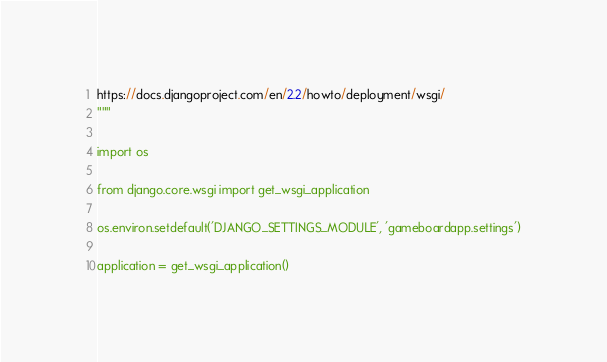Convert code to text. <code><loc_0><loc_0><loc_500><loc_500><_Python_>https://docs.djangoproject.com/en/2.2/howto/deployment/wsgi/
"""

import os

from django.core.wsgi import get_wsgi_application

os.environ.setdefault('DJANGO_SETTINGS_MODULE', 'gameboardapp.settings')

application = get_wsgi_application()
</code> 